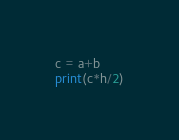Convert code to text. <code><loc_0><loc_0><loc_500><loc_500><_Python_>c = a+b
print(c*h/2)</code> 